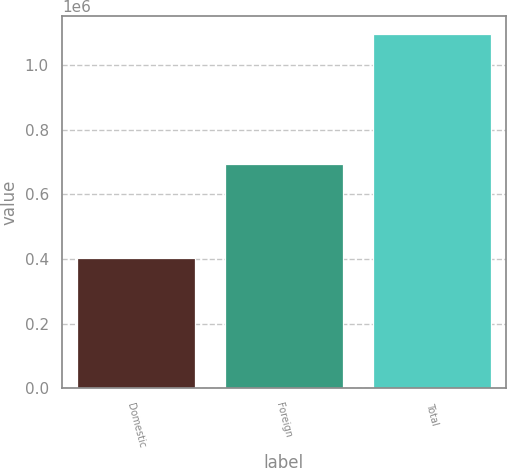Convert chart to OTSL. <chart><loc_0><loc_0><loc_500><loc_500><bar_chart><fcel>Domestic<fcel>Foreign<fcel>Total<nl><fcel>402111<fcel>694106<fcel>1.09622e+06<nl></chart> 